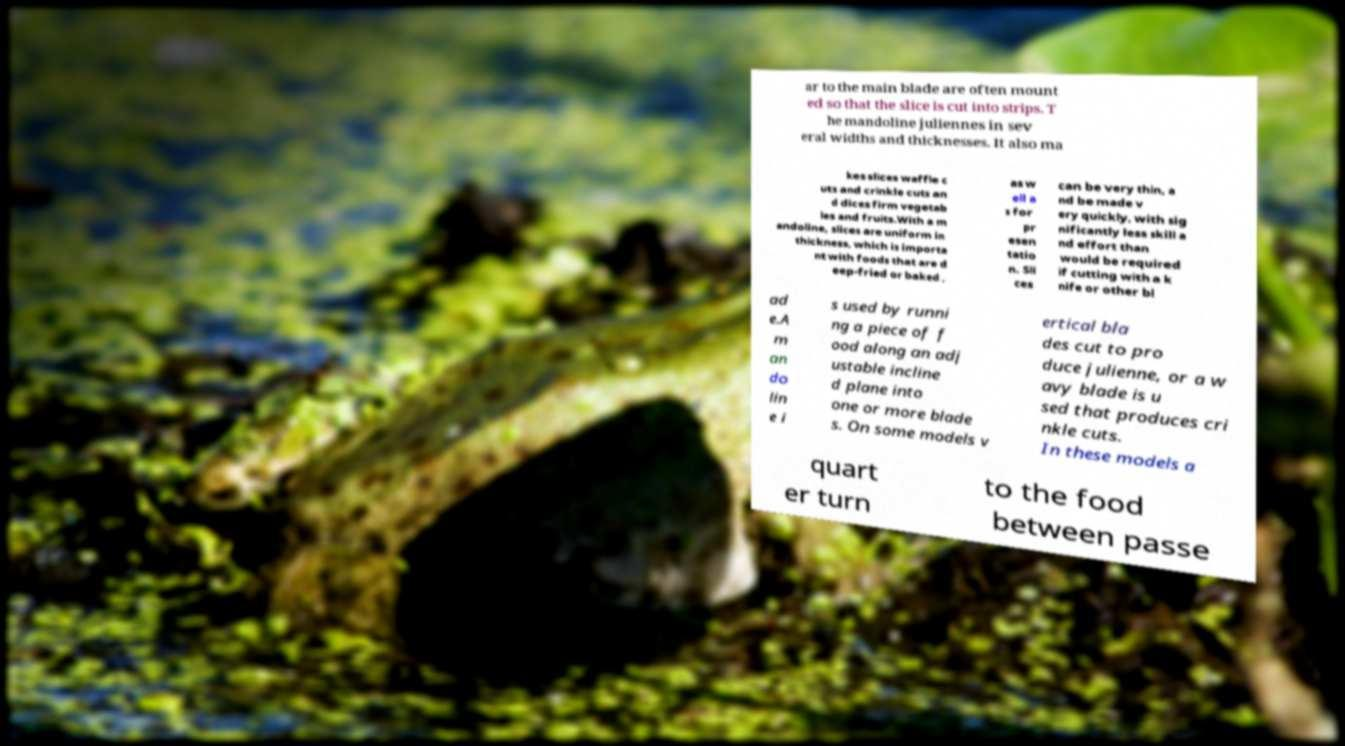What messages or text are displayed in this image? I need them in a readable, typed format. ar to the main blade are often mount ed so that the slice is cut into strips. T he mandoline juliennes in sev eral widths and thicknesses. It also ma kes slices waffle c uts and crinkle cuts an d dices firm vegetab les and fruits.With a m andoline, slices are uniform in thickness, which is importa nt with foods that are d eep-fried or baked , as w ell a s for pr esen tatio n. Sli ces can be very thin, a nd be made v ery quickly, with sig nificantly less skill a nd effort than would be required if cutting with a k nife or other bl ad e.A m an do lin e i s used by runni ng a piece of f ood along an adj ustable incline d plane into one or more blade s. On some models v ertical bla des cut to pro duce julienne, or a w avy blade is u sed that produces cri nkle cuts. In these models a quart er turn to the food between passe 